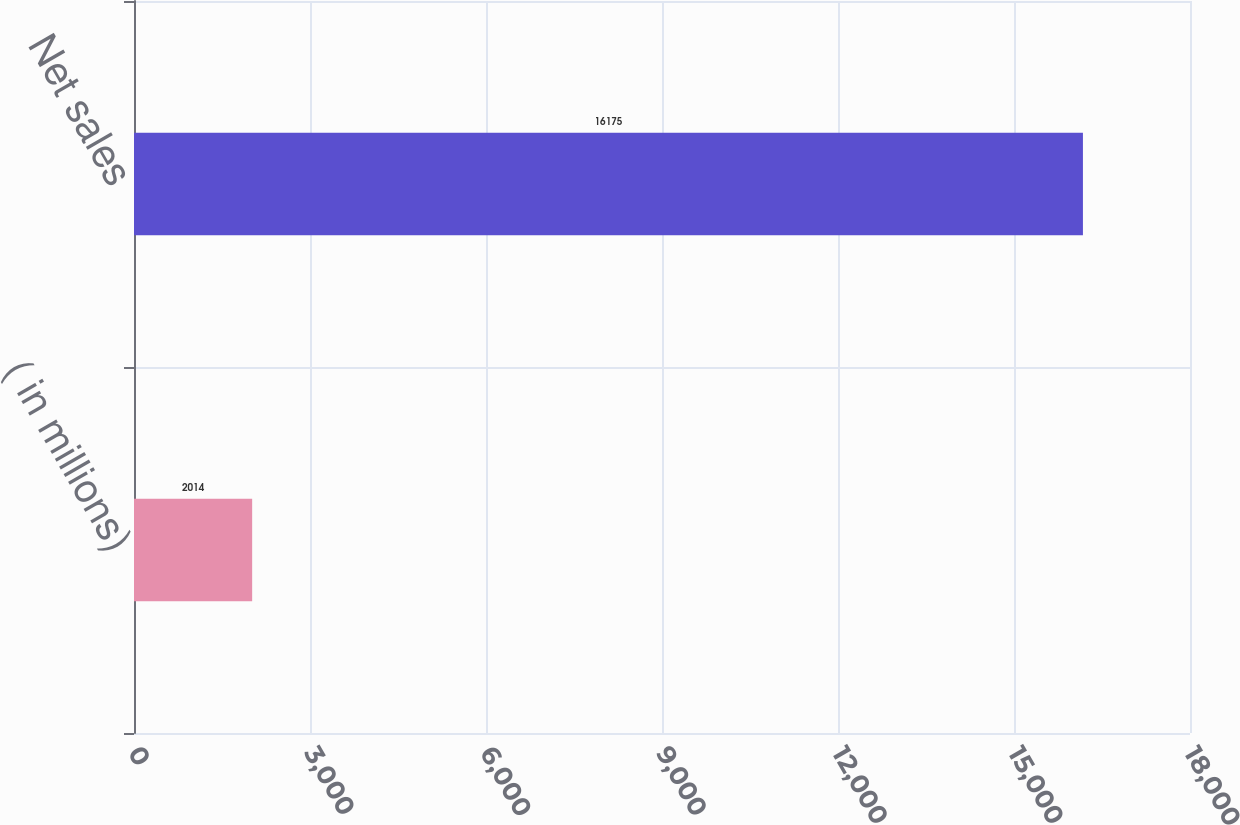Convert chart. <chart><loc_0><loc_0><loc_500><loc_500><bar_chart><fcel>( in millions)<fcel>Net sales<nl><fcel>2014<fcel>16175<nl></chart> 